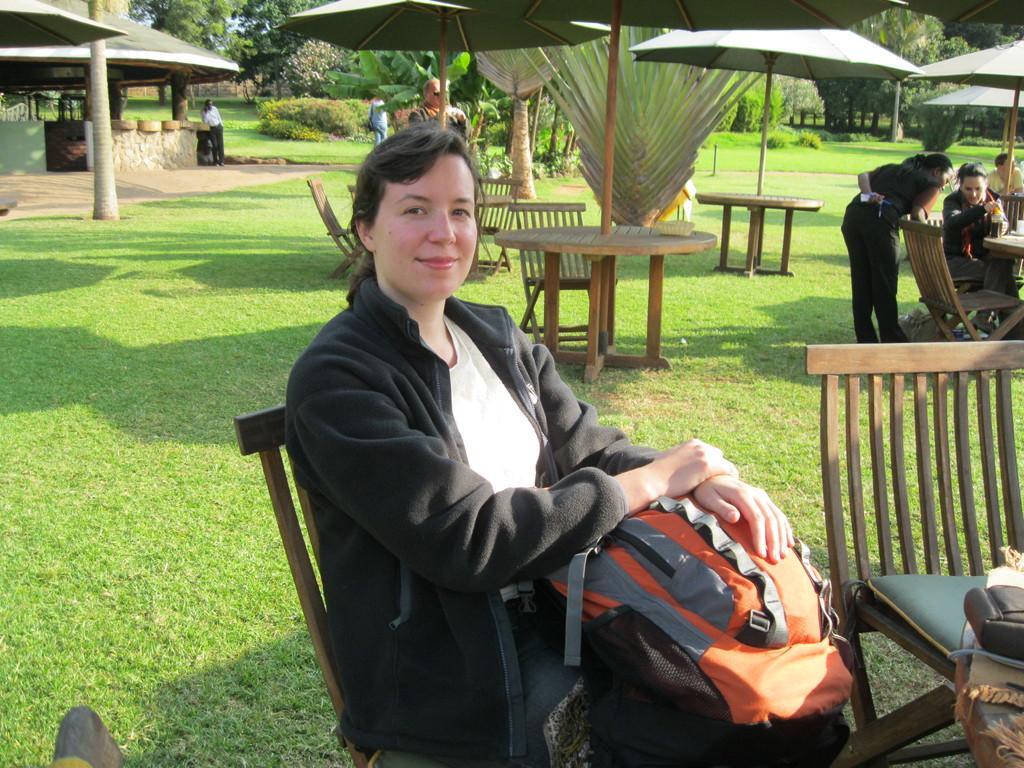Please provide a concise description of this image. There are group of persons in this image. At the middle of the image there is a person wearing black color jacket holding a backpack in her hands and at the bottom right of the image there is a bag which is placed on the chair and at the top right of the image there are two lady persons discussing between them and at the left side of the image a man standing and answering a phone and at the middle of the image there are trees and plants 